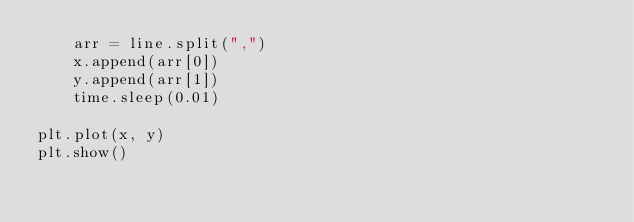<code> <loc_0><loc_0><loc_500><loc_500><_Python_>    arr = line.split(",")
    x.append(arr[0])
    y.append(arr[1])
    time.sleep(0.01)

plt.plot(x, y)
plt.show()
    
</code> 